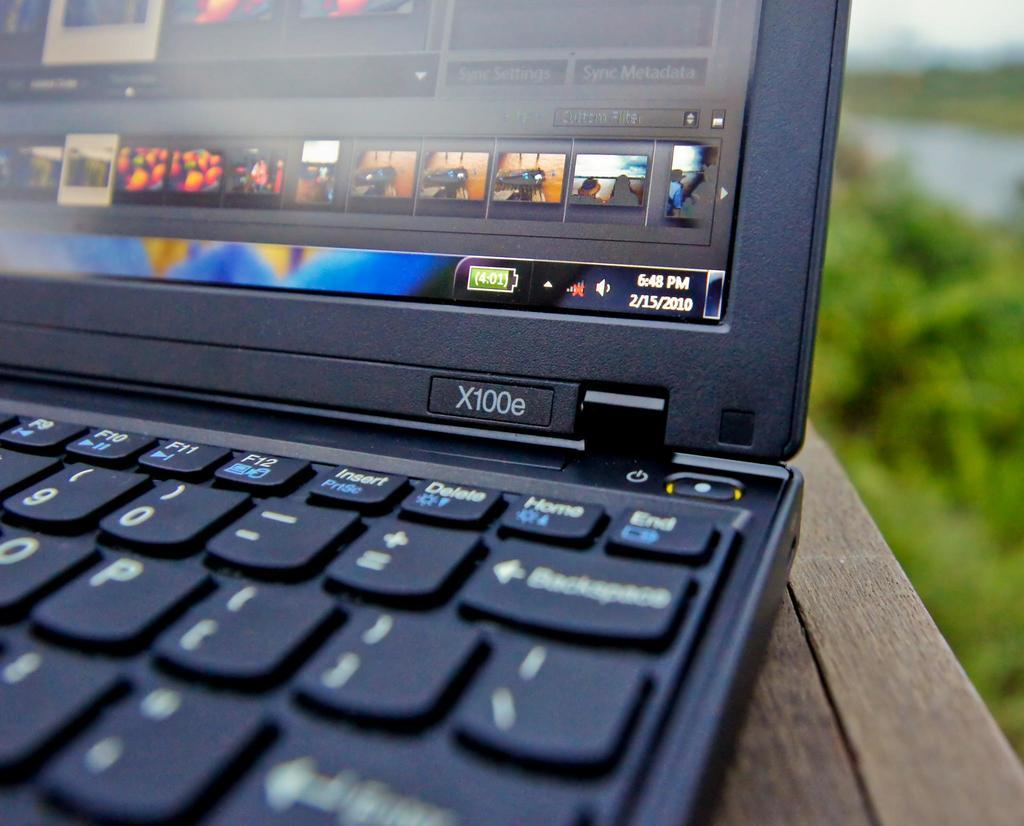<image>
Present a compact description of the photo's key features. A laptop is sitting on a wooden table and is displaying a program with sync settings and sync metadata. 